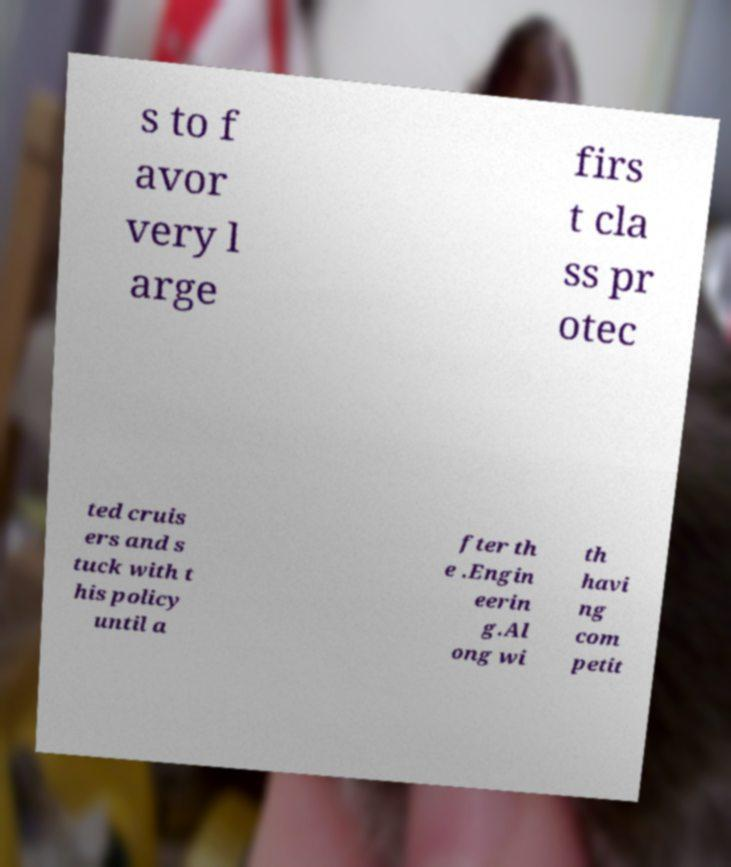I need the written content from this picture converted into text. Can you do that? s to f avor very l arge firs t cla ss pr otec ted cruis ers and s tuck with t his policy until a fter th e .Engin eerin g.Al ong wi th havi ng com petit 